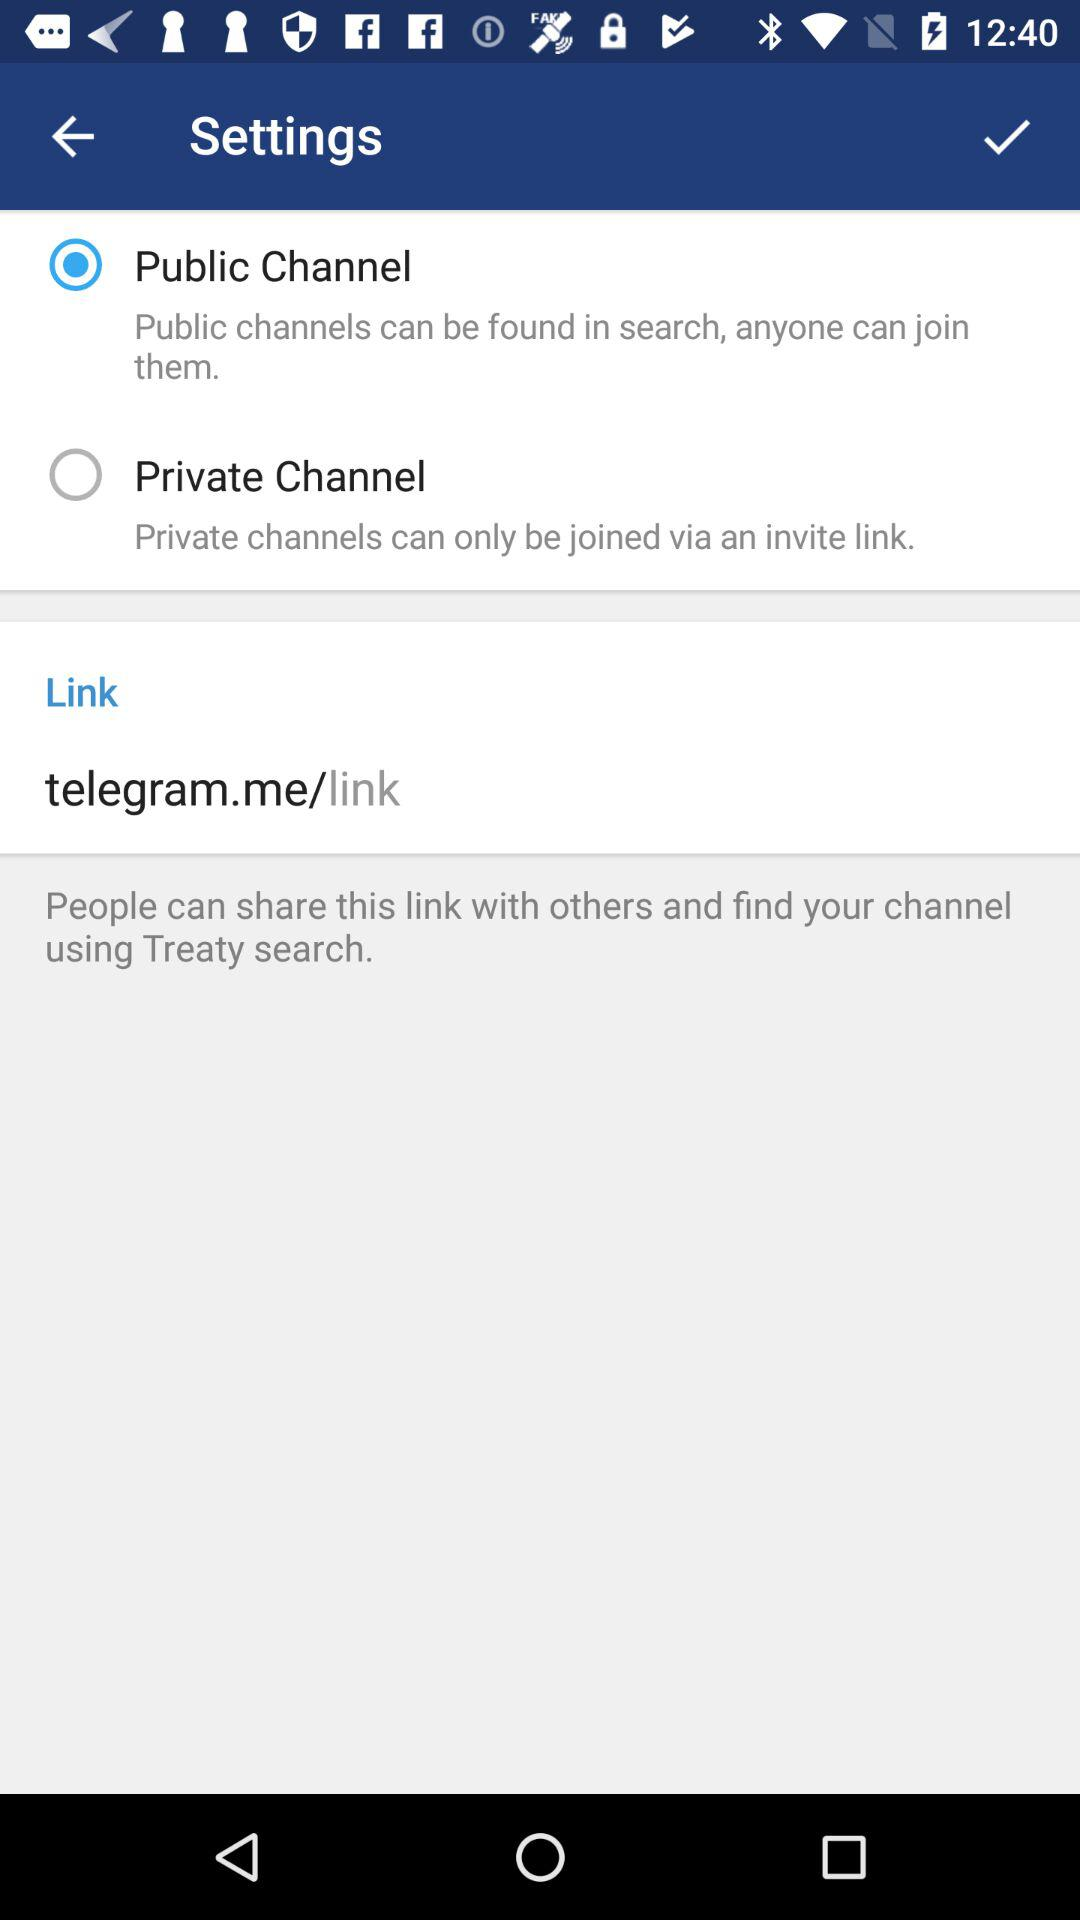What type of channel is selected? The selected type of channel is public. 